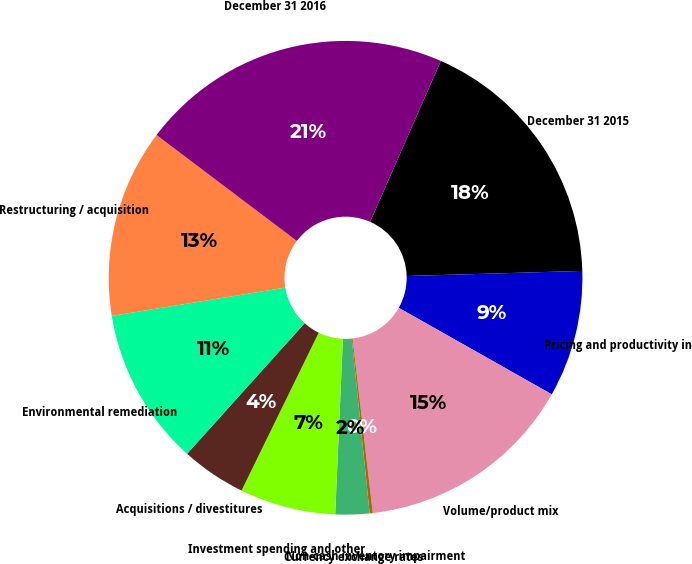<chart> <loc_0><loc_0><loc_500><loc_500><pie_chart><fcel>December 31 2015<fcel>Pricing and productivity in<fcel>Volume/product mix<fcel>Non-cash inventory impairment<fcel>Currency exchange rates<fcel>Investment spending and other<fcel>Acquisitions / divestitures<fcel>Environmental remediation<fcel>Restructuring / acquisition<fcel>December 31 2016<nl><fcel>17.95%<fcel>8.65%<fcel>14.98%<fcel>0.21%<fcel>2.32%<fcel>6.54%<fcel>4.43%<fcel>10.76%<fcel>12.87%<fcel>21.3%<nl></chart> 